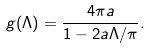Convert formula to latex. <formula><loc_0><loc_0><loc_500><loc_500>g ( \Lambda ) = \frac { 4 \pi a } { 1 - 2 a \Lambda / \pi } .</formula> 